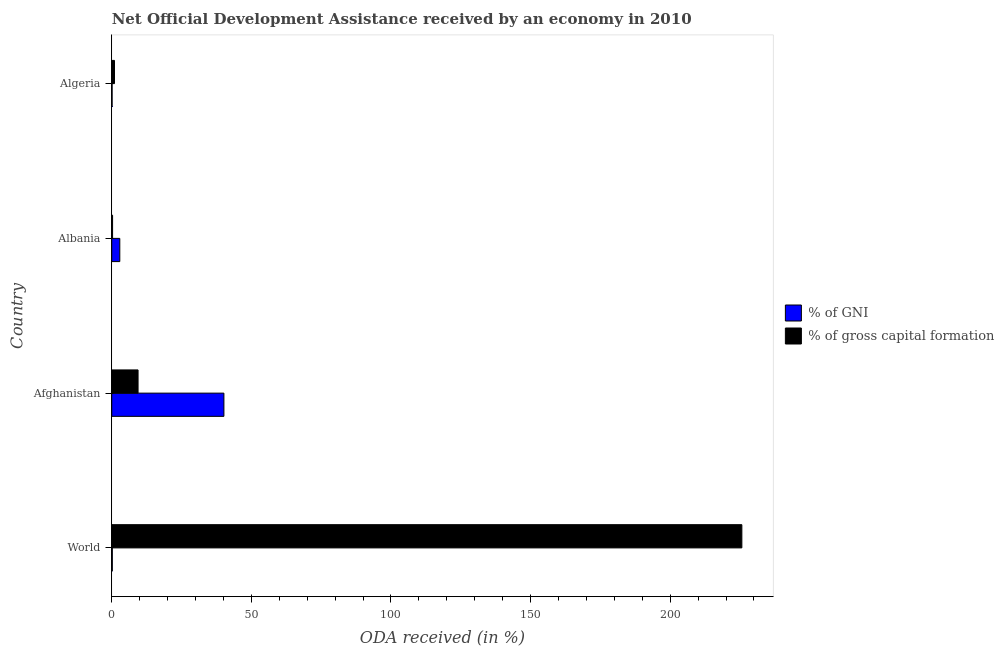Are the number of bars per tick equal to the number of legend labels?
Your answer should be compact. Yes. How many bars are there on the 4th tick from the bottom?
Your answer should be compact. 2. In how many cases, is the number of bars for a given country not equal to the number of legend labels?
Keep it short and to the point. 0. What is the oda received as percentage of gross capital formation in World?
Your response must be concise. 225.67. Across all countries, what is the maximum oda received as percentage of gross capital formation?
Your response must be concise. 225.67. Across all countries, what is the minimum oda received as percentage of gross capital formation?
Keep it short and to the point. 0.3. In which country was the oda received as percentage of gni minimum?
Provide a short and direct response. Algeria. What is the total oda received as percentage of gni in the graph?
Ensure brevity in your answer.  43.38. What is the difference between the oda received as percentage of gni in Algeria and that in World?
Make the answer very short. -0.08. What is the difference between the oda received as percentage of gni in Albania and the oda received as percentage of gross capital formation in Algeria?
Make the answer very short. 1.9. What is the average oda received as percentage of gross capital formation per country?
Your answer should be very brief. 59.09. What is the difference between the oda received as percentage of gni and oda received as percentage of gross capital formation in Algeria?
Keep it short and to the point. -0.86. What is the ratio of the oda received as percentage of gross capital formation in Algeria to that in World?
Keep it short and to the point. 0. What is the difference between the highest and the second highest oda received as percentage of gni?
Provide a succinct answer. 37.28. What is the difference between the highest and the lowest oda received as percentage of gni?
Offer a terse response. 40.05. What does the 2nd bar from the top in Albania represents?
Keep it short and to the point. % of GNI. What does the 1st bar from the bottom in Algeria represents?
Give a very brief answer. % of GNI. What is the difference between two consecutive major ticks on the X-axis?
Your response must be concise. 50. Does the graph contain any zero values?
Make the answer very short. No. Where does the legend appear in the graph?
Give a very brief answer. Center right. What is the title of the graph?
Make the answer very short. Net Official Development Assistance received by an economy in 2010. What is the label or title of the X-axis?
Keep it short and to the point. ODA received (in %). What is the label or title of the Y-axis?
Provide a short and direct response. Country. What is the ODA received (in %) of % of GNI in World?
Make the answer very short. 0.2. What is the ODA received (in %) in % of gross capital formation in World?
Your answer should be very brief. 225.67. What is the ODA received (in %) in % of GNI in Afghanistan?
Your answer should be very brief. 40.17. What is the ODA received (in %) of % of gross capital formation in Afghanistan?
Give a very brief answer. 9.42. What is the ODA received (in %) in % of GNI in Albania?
Offer a terse response. 2.89. What is the ODA received (in %) in % of gross capital formation in Albania?
Provide a succinct answer. 0.3. What is the ODA received (in %) of % of GNI in Algeria?
Your answer should be very brief. 0.12. What is the ODA received (in %) in % of gross capital formation in Algeria?
Your answer should be very brief. 0.99. Across all countries, what is the maximum ODA received (in %) of % of GNI?
Keep it short and to the point. 40.17. Across all countries, what is the maximum ODA received (in %) of % of gross capital formation?
Your answer should be very brief. 225.67. Across all countries, what is the minimum ODA received (in %) in % of GNI?
Offer a terse response. 0.12. Across all countries, what is the minimum ODA received (in %) in % of gross capital formation?
Provide a succinct answer. 0.3. What is the total ODA received (in %) in % of GNI in the graph?
Your answer should be compact. 43.38. What is the total ODA received (in %) of % of gross capital formation in the graph?
Offer a terse response. 236.38. What is the difference between the ODA received (in %) in % of GNI in World and that in Afghanistan?
Keep it short and to the point. -39.97. What is the difference between the ODA received (in %) in % of gross capital formation in World and that in Afghanistan?
Provide a succinct answer. 216.25. What is the difference between the ODA received (in %) of % of GNI in World and that in Albania?
Ensure brevity in your answer.  -2.69. What is the difference between the ODA received (in %) in % of gross capital formation in World and that in Albania?
Give a very brief answer. 225.38. What is the difference between the ODA received (in %) of % of GNI in World and that in Algeria?
Provide a succinct answer. 0.08. What is the difference between the ODA received (in %) of % of gross capital formation in World and that in Algeria?
Offer a very short reply. 224.69. What is the difference between the ODA received (in %) in % of GNI in Afghanistan and that in Albania?
Your answer should be compact. 37.28. What is the difference between the ODA received (in %) in % of gross capital formation in Afghanistan and that in Albania?
Offer a terse response. 9.13. What is the difference between the ODA received (in %) of % of GNI in Afghanistan and that in Algeria?
Keep it short and to the point. 40.05. What is the difference between the ODA received (in %) of % of gross capital formation in Afghanistan and that in Algeria?
Offer a very short reply. 8.44. What is the difference between the ODA received (in %) of % of GNI in Albania and that in Algeria?
Offer a terse response. 2.76. What is the difference between the ODA received (in %) in % of gross capital formation in Albania and that in Algeria?
Keep it short and to the point. -0.69. What is the difference between the ODA received (in %) in % of GNI in World and the ODA received (in %) in % of gross capital formation in Afghanistan?
Offer a very short reply. -9.23. What is the difference between the ODA received (in %) in % of GNI in World and the ODA received (in %) in % of gross capital formation in Albania?
Ensure brevity in your answer.  -0.1. What is the difference between the ODA received (in %) of % of GNI in World and the ODA received (in %) of % of gross capital formation in Algeria?
Provide a short and direct response. -0.79. What is the difference between the ODA received (in %) of % of GNI in Afghanistan and the ODA received (in %) of % of gross capital formation in Albania?
Ensure brevity in your answer.  39.87. What is the difference between the ODA received (in %) in % of GNI in Afghanistan and the ODA received (in %) in % of gross capital formation in Algeria?
Your answer should be very brief. 39.18. What is the difference between the ODA received (in %) in % of GNI in Albania and the ODA received (in %) in % of gross capital formation in Algeria?
Your answer should be very brief. 1.9. What is the average ODA received (in %) of % of GNI per country?
Your answer should be very brief. 10.84. What is the average ODA received (in %) in % of gross capital formation per country?
Keep it short and to the point. 59.09. What is the difference between the ODA received (in %) of % of GNI and ODA received (in %) of % of gross capital formation in World?
Ensure brevity in your answer.  -225.47. What is the difference between the ODA received (in %) of % of GNI and ODA received (in %) of % of gross capital formation in Afghanistan?
Provide a succinct answer. 30.74. What is the difference between the ODA received (in %) in % of GNI and ODA received (in %) in % of gross capital formation in Albania?
Offer a terse response. 2.59. What is the difference between the ODA received (in %) of % of GNI and ODA received (in %) of % of gross capital formation in Algeria?
Offer a very short reply. -0.86. What is the ratio of the ODA received (in %) in % of GNI in World to that in Afghanistan?
Your response must be concise. 0.01. What is the ratio of the ODA received (in %) in % of gross capital formation in World to that in Afghanistan?
Provide a succinct answer. 23.94. What is the ratio of the ODA received (in %) of % of GNI in World to that in Albania?
Your answer should be compact. 0.07. What is the ratio of the ODA received (in %) in % of gross capital formation in World to that in Albania?
Make the answer very short. 760. What is the ratio of the ODA received (in %) of % of GNI in World to that in Algeria?
Offer a terse response. 1.62. What is the ratio of the ODA received (in %) in % of gross capital formation in World to that in Algeria?
Offer a very short reply. 229.07. What is the ratio of the ODA received (in %) in % of GNI in Afghanistan to that in Albania?
Keep it short and to the point. 13.92. What is the ratio of the ODA received (in %) in % of gross capital formation in Afghanistan to that in Albania?
Your answer should be very brief. 31.74. What is the ratio of the ODA received (in %) in % of GNI in Afghanistan to that in Algeria?
Offer a very short reply. 326.09. What is the ratio of the ODA received (in %) of % of gross capital formation in Afghanistan to that in Algeria?
Provide a short and direct response. 9.57. What is the ratio of the ODA received (in %) of % of GNI in Albania to that in Algeria?
Ensure brevity in your answer.  23.42. What is the ratio of the ODA received (in %) of % of gross capital formation in Albania to that in Algeria?
Offer a terse response. 0.3. What is the difference between the highest and the second highest ODA received (in %) in % of GNI?
Your answer should be compact. 37.28. What is the difference between the highest and the second highest ODA received (in %) of % of gross capital formation?
Offer a very short reply. 216.25. What is the difference between the highest and the lowest ODA received (in %) in % of GNI?
Give a very brief answer. 40.05. What is the difference between the highest and the lowest ODA received (in %) of % of gross capital formation?
Your response must be concise. 225.38. 